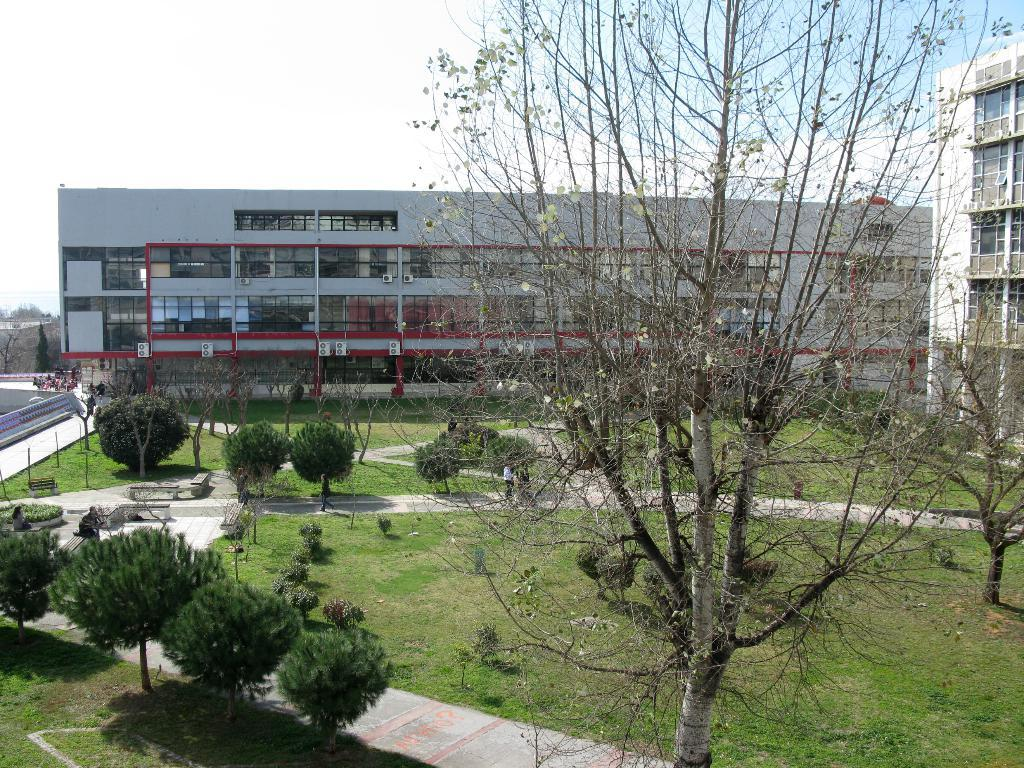What type of structure can be seen in the image? There is a building in the image. What is visible in the background of the image? There is a sky visible in the image. What type of vegetation is present in the image? There is a tree and plants visible in the image. What type of ground cover is visible in the image? There is grass visible in the image. Can you see a rake being used in the image? There is no rake present in the image. How many bees can be seen flying around the tree in the image? There are no bees visible in the image. 